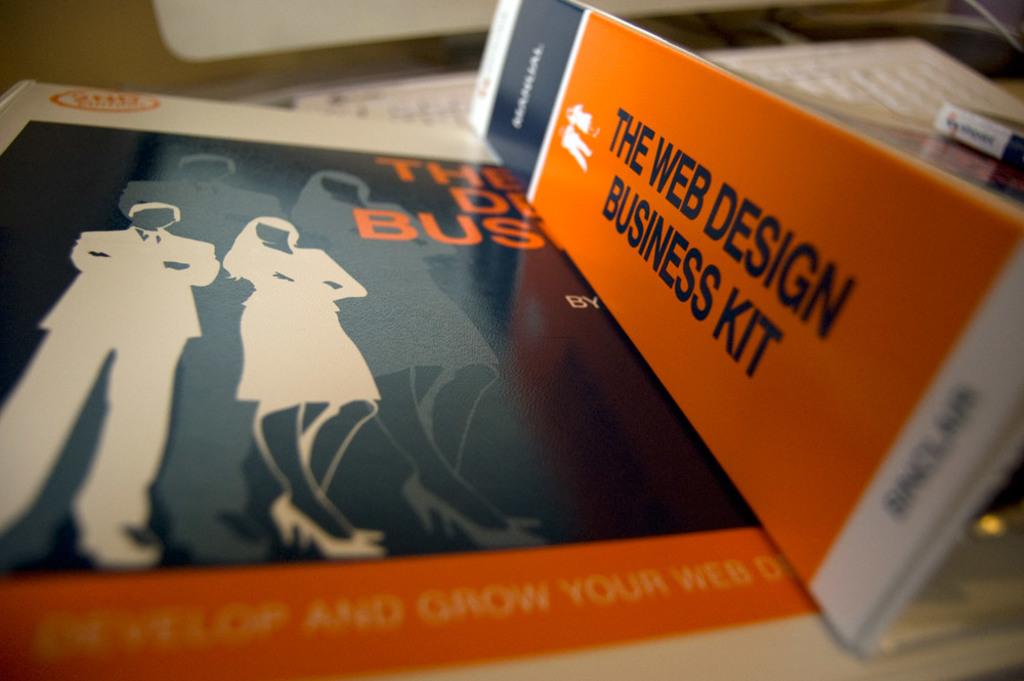What is the business kit about?
Provide a succinct answer. Web design. What type of book is this?
Ensure brevity in your answer.  Web design. 